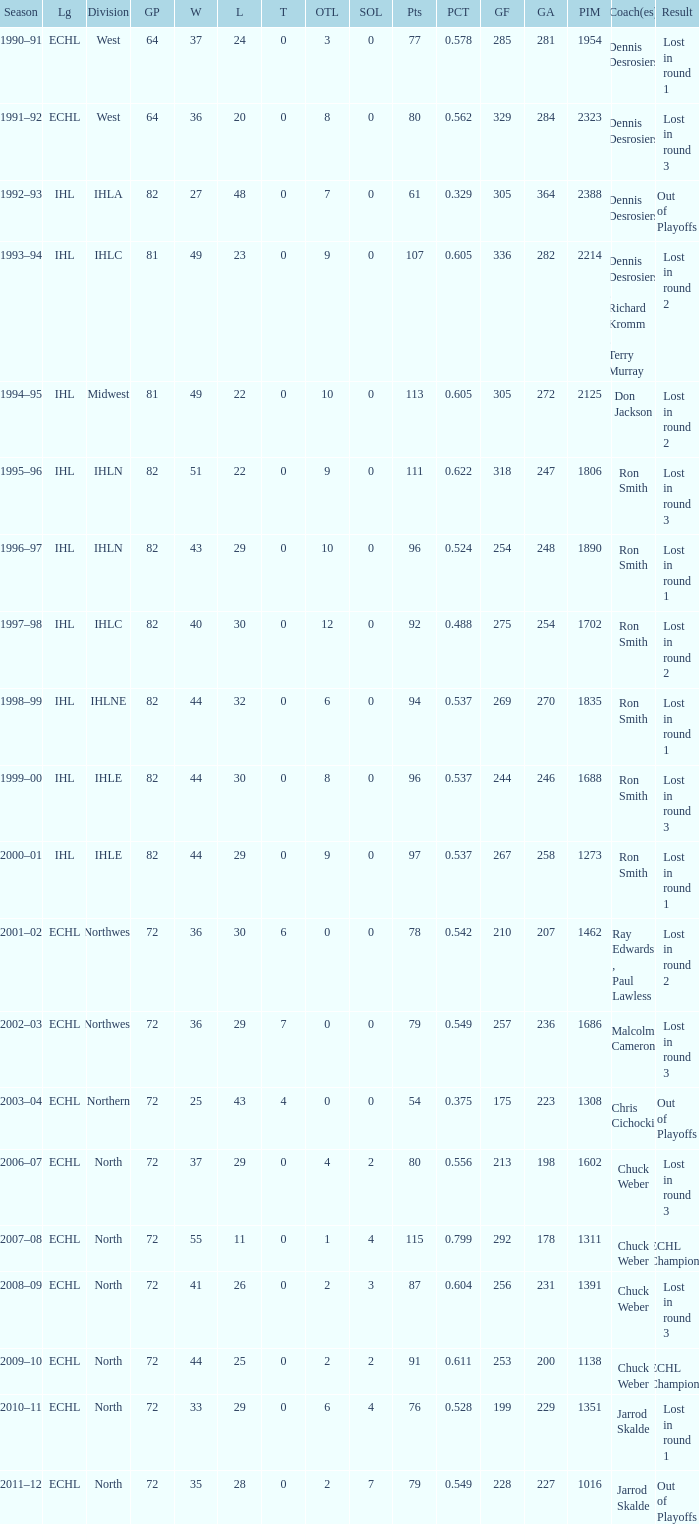Could you parse the entire table? {'header': ['Season', 'Lg', 'Division', 'GP', 'W', 'L', 'T', 'OTL', 'SOL', 'Pts', 'PCT', 'GF', 'GA', 'PIM', 'Coach(es)', 'Result'], 'rows': [['1990–91', 'ECHL', 'West', '64', '37', '24', '0', '3', '0', '77', '0.578', '285', '281', '1954', 'Dennis Desrosiers', 'Lost in round 1'], ['1991–92', 'ECHL', 'West', '64', '36', '20', '0', '8', '0', '80', '0.562', '329', '284', '2323', 'Dennis Desrosiers', 'Lost in round 3'], ['1992–93', 'IHL', 'IHLA', '82', '27', '48', '0', '7', '0', '61', '0.329', '305', '364', '2388', 'Dennis Desrosiers', 'Out of Playoffs'], ['1993–94', 'IHL', 'IHLC', '81', '49', '23', '0', '9', '0', '107', '0.605', '336', '282', '2214', 'Dennis Desrosiers , Richard Kromm , Terry Murray', 'Lost in round 2'], ['1994–95', 'IHL', 'Midwest', '81', '49', '22', '0', '10', '0', '113', '0.605', '305', '272', '2125', 'Don Jackson', 'Lost in round 2'], ['1995–96', 'IHL', 'IHLN', '82', '51', '22', '0', '9', '0', '111', '0.622', '318', '247', '1806', 'Ron Smith', 'Lost in round 3'], ['1996–97', 'IHL', 'IHLN', '82', '43', '29', '0', '10', '0', '96', '0.524', '254', '248', '1890', 'Ron Smith', 'Lost in round 1'], ['1997–98', 'IHL', 'IHLC', '82', '40', '30', '0', '12', '0', '92', '0.488', '275', '254', '1702', 'Ron Smith', 'Lost in round 2'], ['1998–99', 'IHL', 'IHLNE', '82', '44', '32', '0', '6', '0', '94', '0.537', '269', '270', '1835', 'Ron Smith', 'Lost in round 1'], ['1999–00', 'IHL', 'IHLE', '82', '44', '30', '0', '8', '0', '96', '0.537', '244', '246', '1688', 'Ron Smith', 'Lost in round 3'], ['2000–01', 'IHL', 'IHLE', '82', '44', '29', '0', '9', '0', '97', '0.537', '267', '258', '1273', 'Ron Smith', 'Lost in round 1'], ['2001–02', 'ECHL', 'Northwest', '72', '36', '30', '6', '0', '0', '78', '0.542', '210', '207', '1462', 'Ray Edwards , Paul Lawless', 'Lost in round 2'], ['2002–03', 'ECHL', 'Northwest', '72', '36', '29', '7', '0', '0', '79', '0.549', '257', '236', '1686', 'Malcolm Cameron', 'Lost in round 3'], ['2003–04', 'ECHL', 'Northern', '72', '25', '43', '4', '0', '0', '54', '0.375', '175', '223', '1308', 'Chris Cichocki', 'Out of Playoffs'], ['2006–07', 'ECHL', 'North', '72', '37', '29', '0', '4', '2', '80', '0.556', '213', '198', '1602', 'Chuck Weber', 'Lost in round 3'], ['2007–08', 'ECHL', 'North', '72', '55', '11', '0', '1', '4', '115', '0.799', '292', '178', '1311', 'Chuck Weber', 'ECHL Champions'], ['2008–09', 'ECHL', 'North', '72', '41', '26', '0', '2', '3', '87', '0.604', '256', '231', '1391', 'Chuck Weber', 'Lost in round 3'], ['2009–10', 'ECHL', 'North', '72', '44', '25', '0', '2', '2', '91', '0.611', '253', '200', '1138', 'Chuck Weber', 'ECHL Champions'], ['2010–11', 'ECHL', 'North', '72', '33', '29', '0', '6', '4', '76', '0.528', '199', '229', '1351', 'Jarrod Skalde', 'Lost in round 1'], ['2011–12', 'ECHL', 'North', '72', '35', '28', '0', '2', '7', '79', '0.549', '228', '227', '1016', 'Jarrod Skalde', 'Out of Playoffs']]} What was the maximum OTL if L is 28? 2.0. 